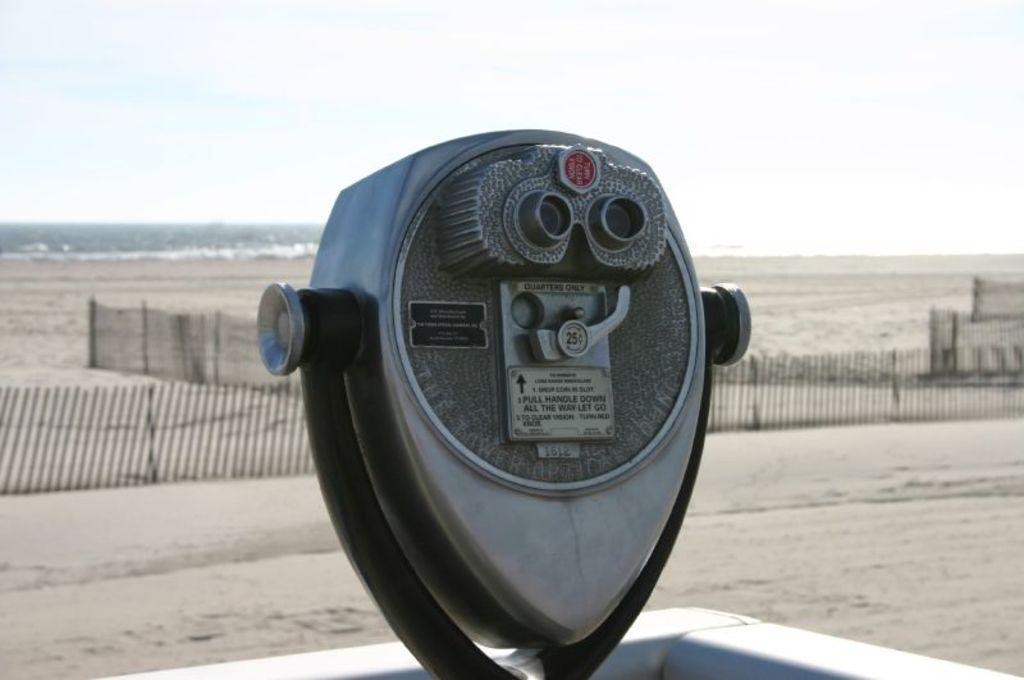In one or two sentences, can you explain what this image depicts? In this picture, it looks like an iron object. On the iron object there are two small boards and screws. Behind the object there is the fence, the sky and it looks like the sea. 